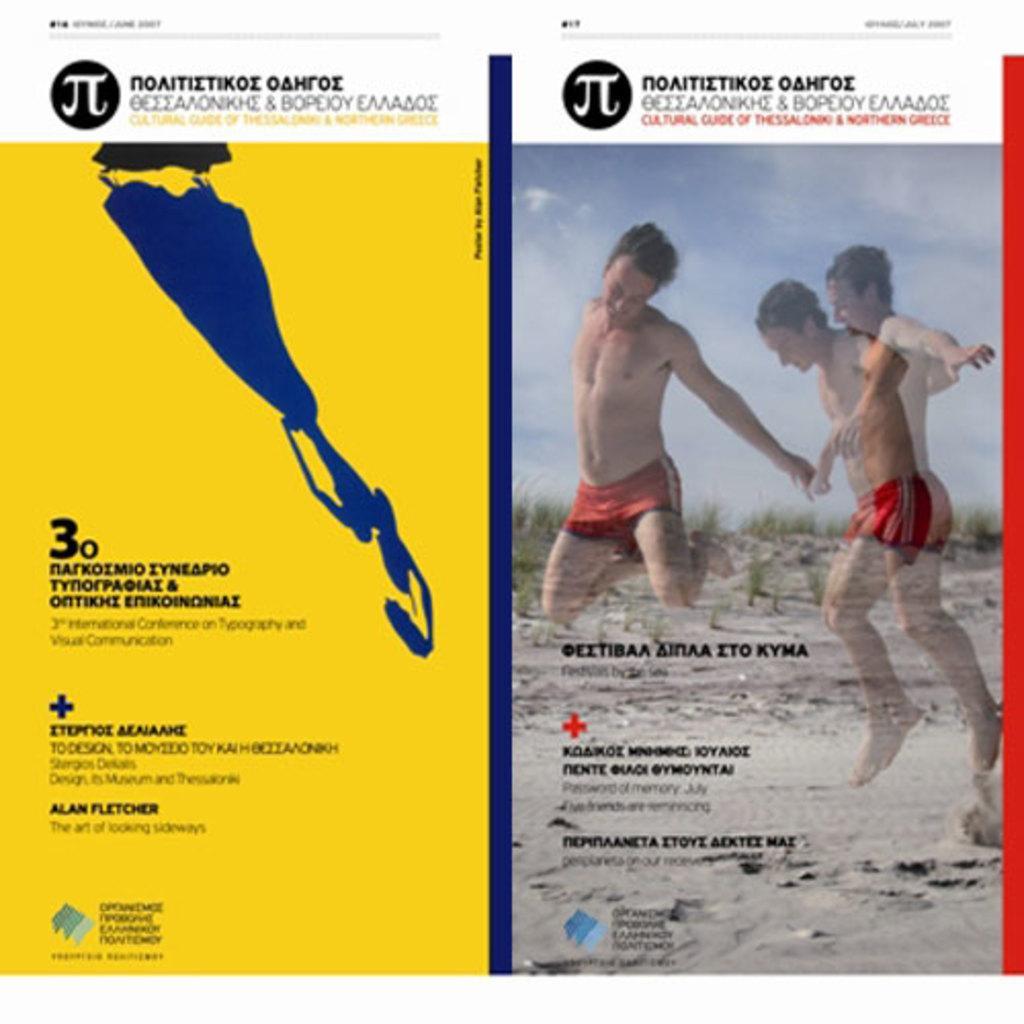How would you summarize this image in a sentence or two? This image consists of a poster. On this poster, I can see some text and two men who are jumping. In the background there are few plants on the ground. 